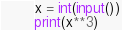<code> <loc_0><loc_0><loc_500><loc_500><_Python_>x = int(input())
print(x**3)
</code> 